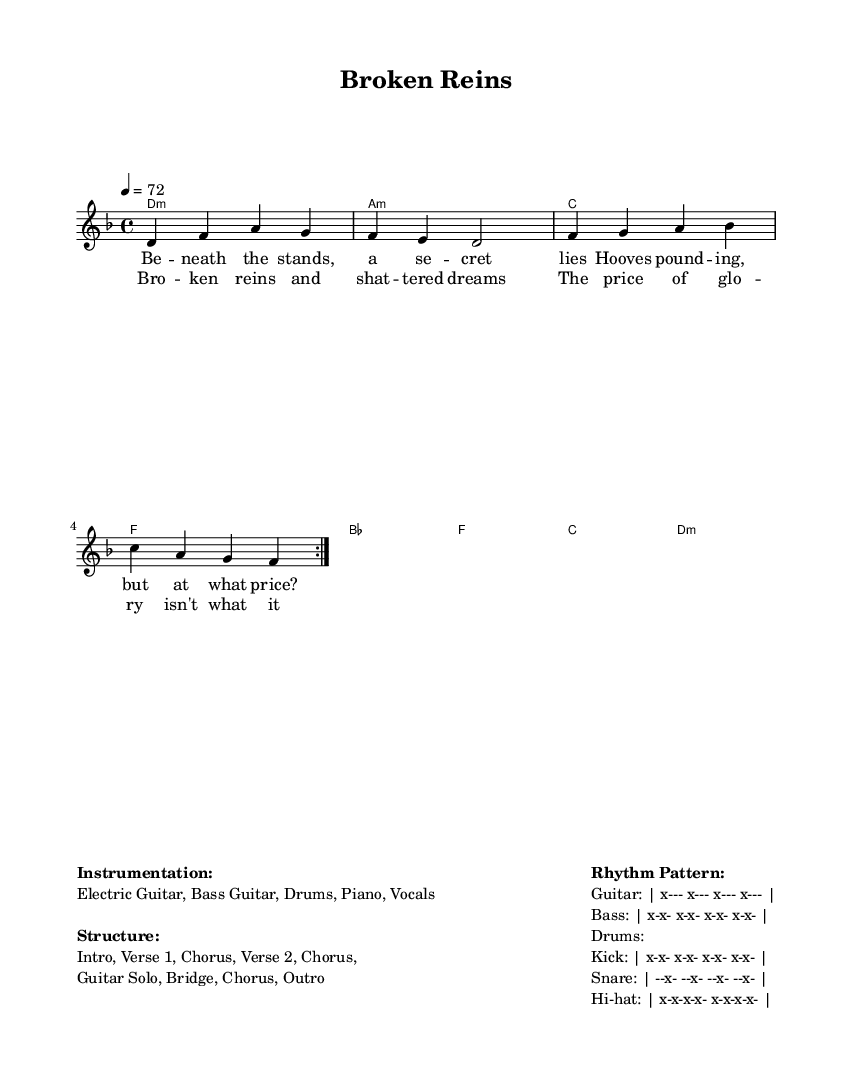What is the key signature of this music? The key signature is shown at the beginning of the score and indicates D minor, which has one flat (B flat).
Answer: D minor What is the time signature of this music? The time signature indicates the number of beats in each measure and is shown as 4/4 at the beginning of the score, meaning there are four beats per measure.
Answer: 4/4 What is the tempo marking for this piece? The tempo marking in the score states "4 = 72," indicating that there are 72 beats per minute, with the note value of a quarter note receiving one beat.
Answer: 72 How many sections are there in the structure of this piece? The structure includes an introduction, two verses, a chorus, a guitar solo, a bridge, and an outro, leading to a total of seven sections.
Answer: 7 What instruments are indicated for this piece? The section at the end of the score lists the instrumentation, which includes Electric Guitar, Bass Guitar, Drums, Piano, and Vocals, making it clear what instruments are used in the performance.
Answer: Electric Guitar, Bass Guitar, Drums, Piano, Vocals What is the primary theme of the lyrics? The lyrics discuss moral dilemmas related to the treatment and experiences of racehorses, reflecting the dark realities behind fame and success, particularly in sports.
Answer: Ethics and moral dilemmas 